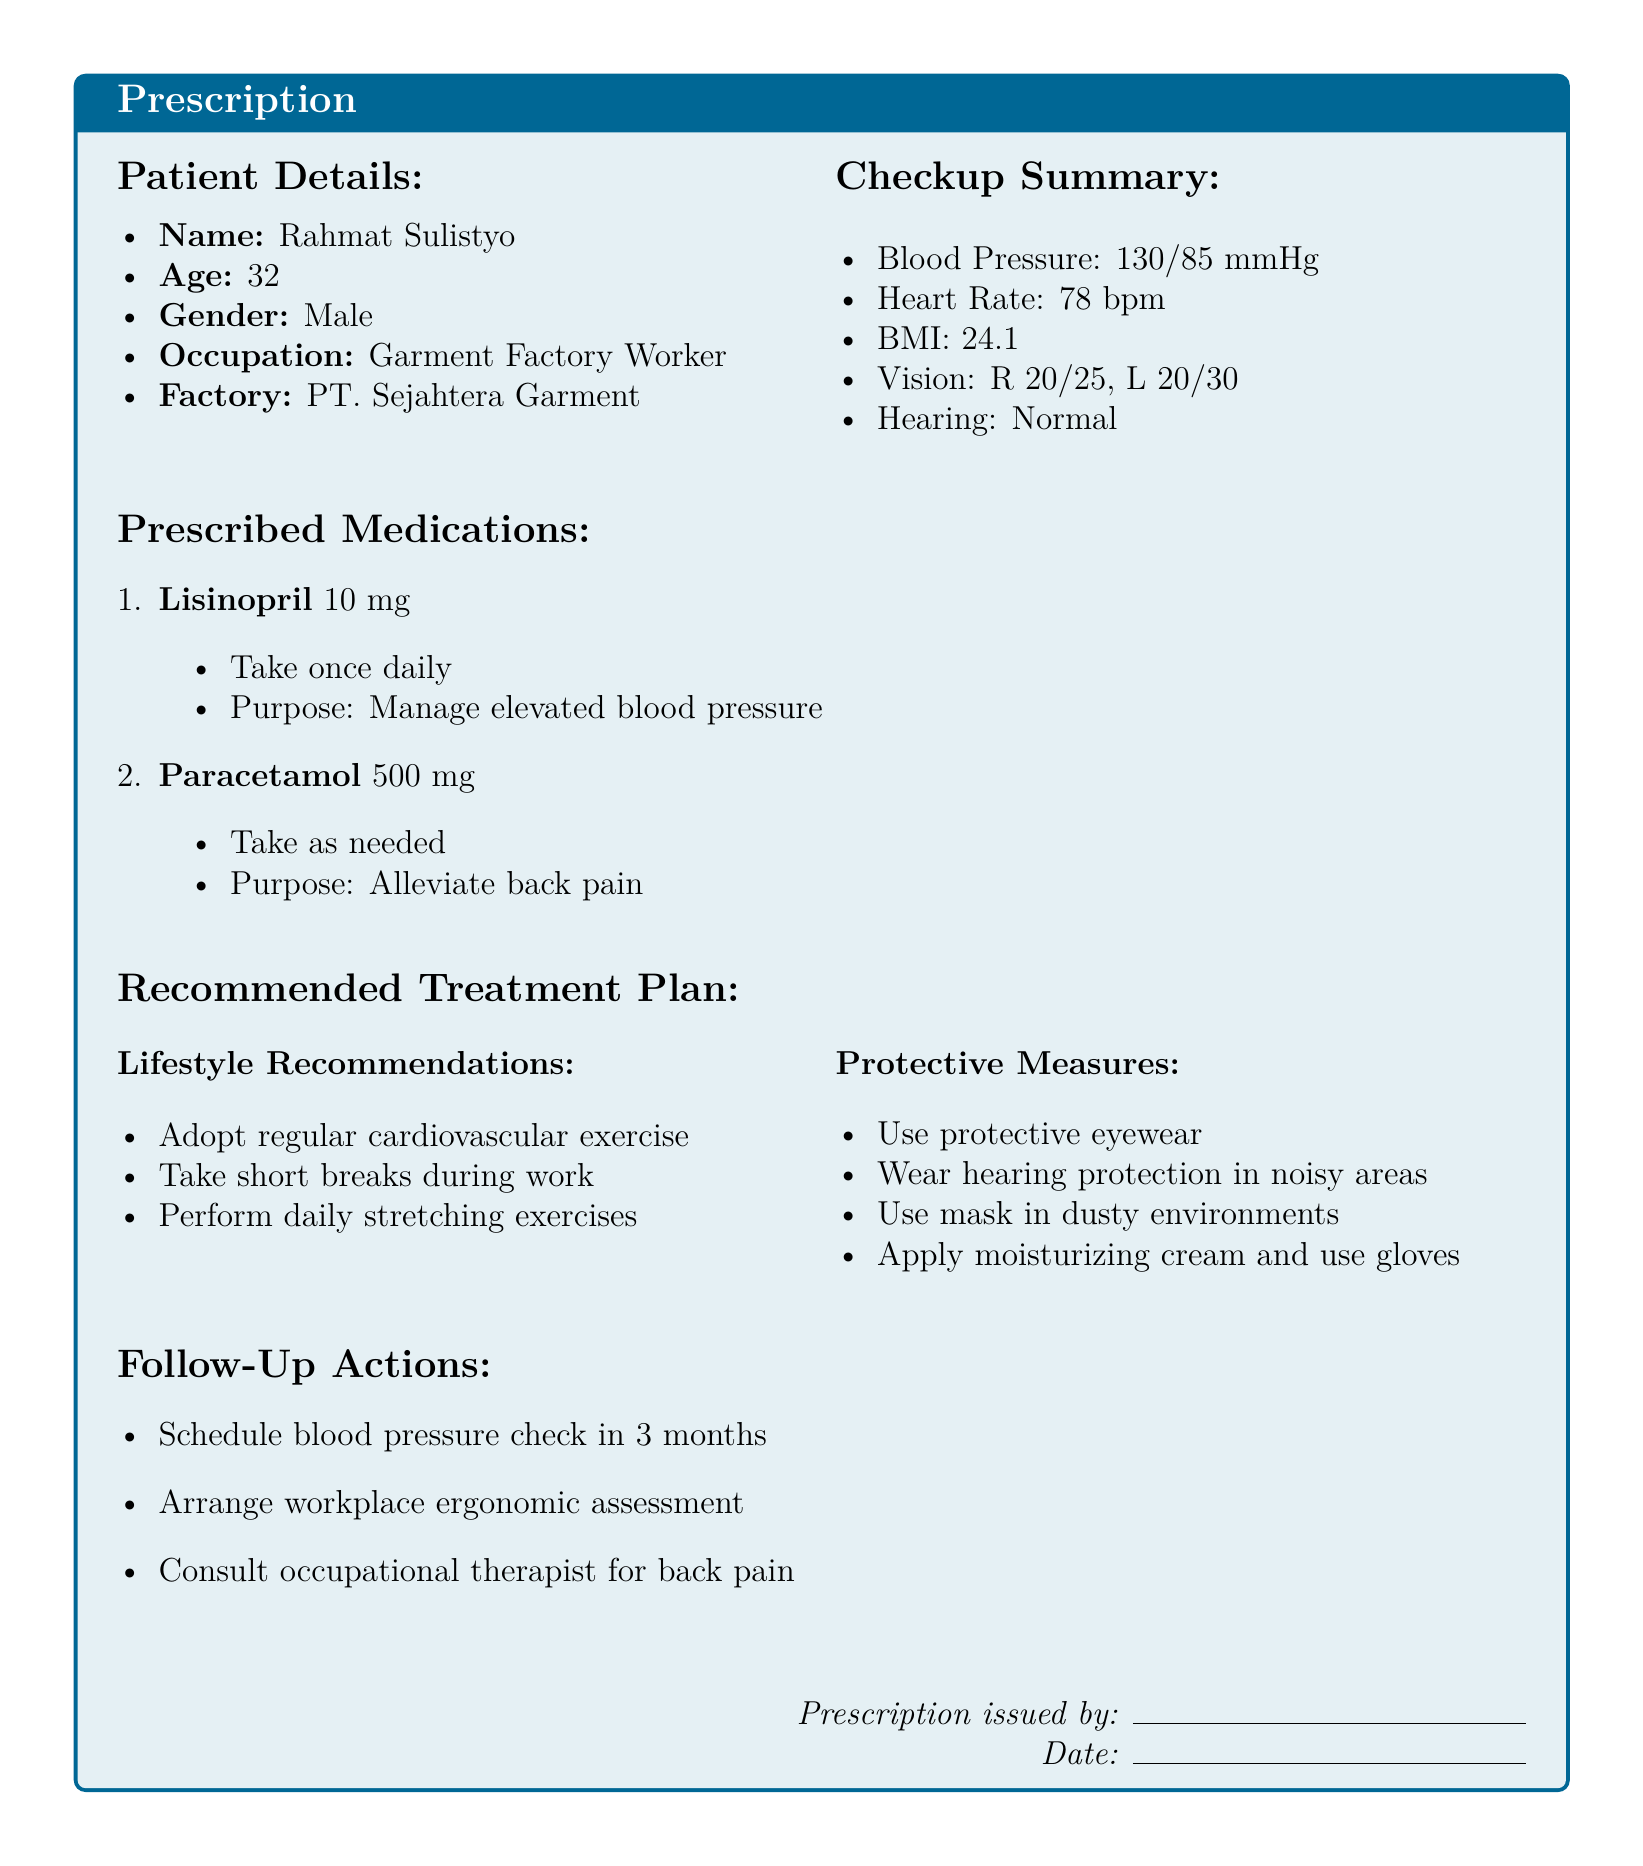what is the patient's name? The patient's name is listed in the Patient Details section of the document.
Answer: Rahmat Sulistyo what is the prescribed medication for back pain? The medication prescribed for back pain is found in the Prescribed Medications section.
Answer: Paracetamol 500 mg how often should Lisinopril be taken? The frequency of taking Lisinopril is mentioned in the Prescribed Medications section.
Answer: Once daily what is the recommended follow-up action for blood pressure? The follow-up action for blood pressure is stated in the Follow-Up Actions section.
Answer: Schedule blood pressure check in 3 months how many lifestyle recommendations are listed? The number of lifestyle recommendations can be counted in the Recommended Treatment Plan section.
Answer: Three what is the purpose of Lisinopril? The purpose of Lisinopril is provided in the Prescribed Medications section.
Answer: Manage elevated blood pressure what type of exercise is recommended? The type of exercise recommended is in the Lifestyle Recommendations section.
Answer: Cardiovascular exercise what protective measure is recommended for dusty environments? The protective measure for dusty environments is specified in the Protective Measures section.
Answer: Use mask what is the patient's age? The patient's age is indicated in the Patient Details section of the document.
Answer: 32 